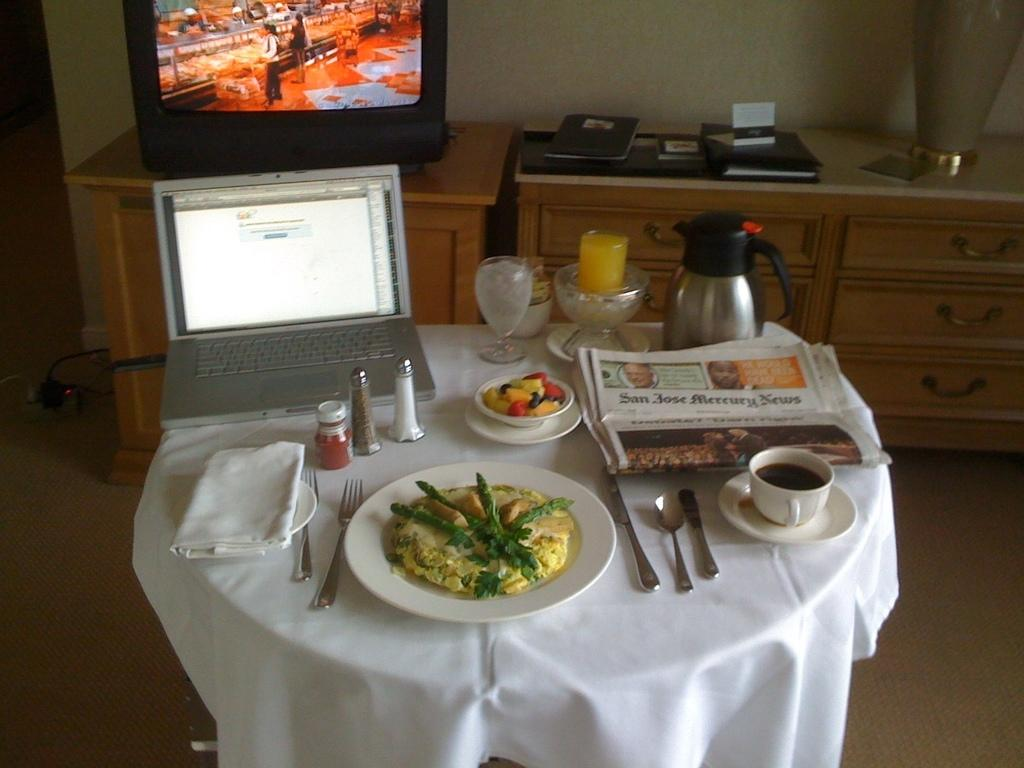What is present on the surface in the image? There is a plate in the image. What utensils can be seen in the image? There are spoons in the image. What type of container is visible in the image? There is a cup in the image. What electronic device is present in the image? There is a paper laptop in the image. What can be seen in the background of the image? There is a television, a cupboard, and a wall in the background of the image. What type of sack is being used to carry the goose in the image? There is no sack or goose present in the image. What type of underwear is visible on the wall in the image? There is no underwear visible on the wall in the image. 